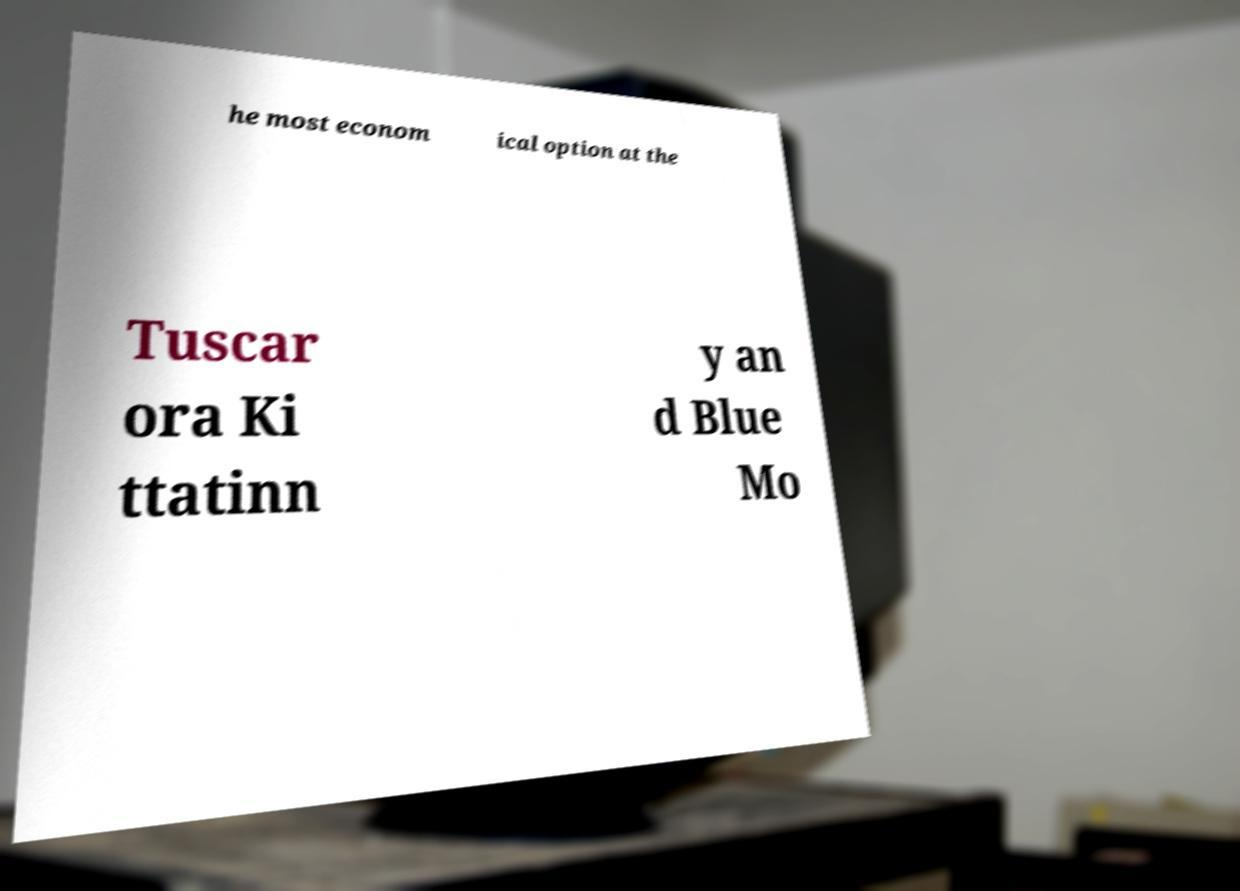What messages or text are displayed in this image? I need them in a readable, typed format. he most econom ical option at the Tuscar ora Ki ttatinn y an d Blue Mo 